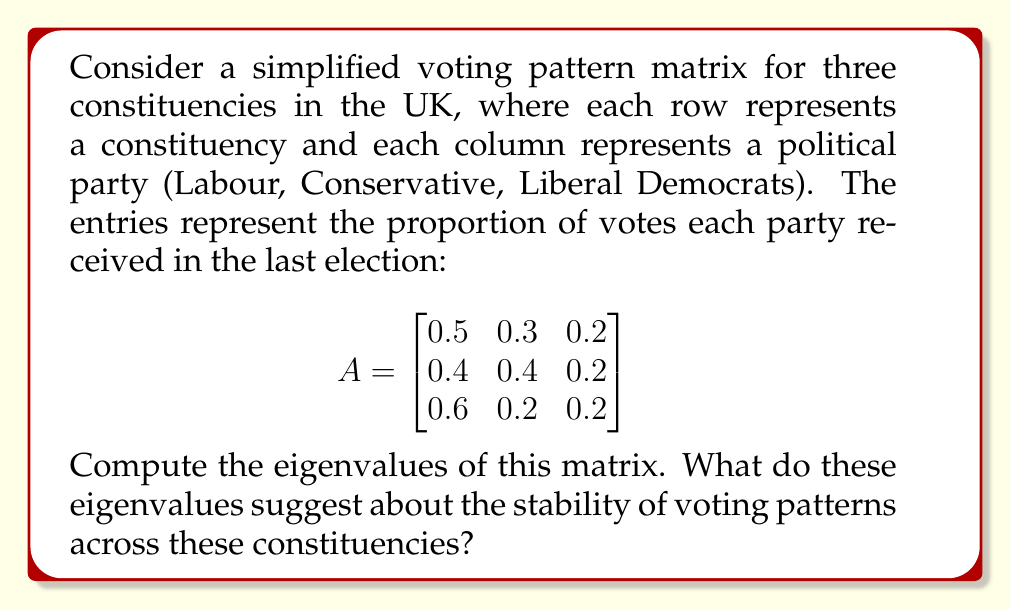Give your solution to this math problem. To find the eigenvalues of matrix A, we need to solve the characteristic equation:

$$det(A - \lambda I) = 0$$

Where $I$ is the 3x3 identity matrix and $\lambda$ represents the eigenvalues.

Step 1: Set up the characteristic equation:

$$det\begin{pmatrix}
0.5-\lambda & 0.3 & 0.2 \\
0.4 & 0.4-\lambda & 0.2 \\
0.6 & 0.2 & 0.2-\lambda
\end{pmatrix} = 0$$

Step 2: Expand the determinant:

$$(0.5-\lambda)[(0.4-\lambda)(0.2-\lambda) - 0.04] - 0.3[0.4(0.2-\lambda) - 0.12] + 0.2[0.4(0.2) - 0.6(0.4-\lambda)] = 0$$

Step 3: Simplify:

$$\lambda^3 - 1.1\lambda^2 + 0.06\lambda + 0.024 = 0$$

Step 4: Solve this cubic equation. The solutions are the eigenvalues:

$\lambda_1 = 1$
$\lambda_2 \approx 0.0789$
$\lambda_3 \approx 0.0211$

The dominant eigenvalue of 1 suggests a stable long-term voting pattern across these constituencies. The two smaller eigenvalues indicate minor fluctuations or trends that may not significantly impact the overall voting landscape.

For a Labour Party activist, this result implies that the current voting distribution is relatively stable, which could be seen as either an opportunity to maintain strong support in favorable constituencies or a challenge in areas where Labour isn't the leading party.
Answer: $\lambda_1 = 1$, $\lambda_2 \approx 0.0789$, $\lambda_3 \approx 0.0211$ 